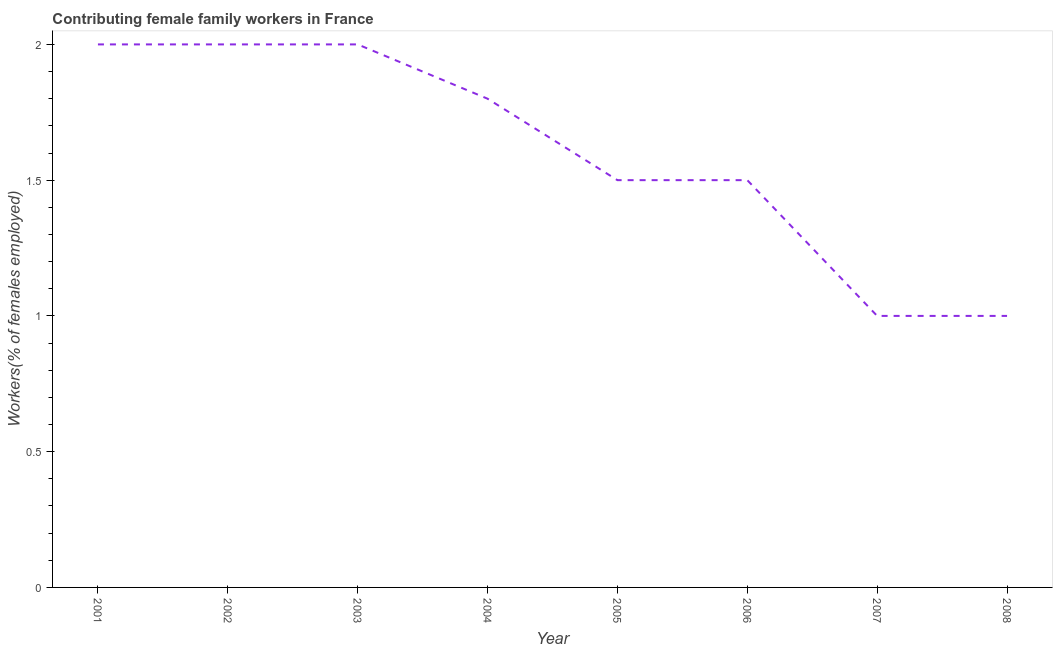Across all years, what is the minimum contributing female family workers?
Ensure brevity in your answer.  1. What is the sum of the contributing female family workers?
Offer a terse response. 12.8. What is the average contributing female family workers per year?
Your answer should be very brief. 1.6. What is the median contributing female family workers?
Offer a terse response. 1.65. In how many years, is the contributing female family workers greater than 1.1 %?
Give a very brief answer. 6. Do a majority of the years between 2001 and 2005 (inclusive) have contributing female family workers greater than 0.30000000000000004 %?
Give a very brief answer. Yes. What is the ratio of the contributing female family workers in 2004 to that in 2008?
Provide a succinct answer. 1.8. Is the sum of the contributing female family workers in 2005 and 2008 greater than the maximum contributing female family workers across all years?
Keep it short and to the point. Yes. Does the contributing female family workers monotonically increase over the years?
Provide a short and direct response. No. What is the difference between two consecutive major ticks on the Y-axis?
Provide a short and direct response. 0.5. Does the graph contain any zero values?
Provide a short and direct response. No. Does the graph contain grids?
Provide a succinct answer. No. What is the title of the graph?
Your answer should be compact. Contributing female family workers in France. What is the label or title of the X-axis?
Give a very brief answer. Year. What is the label or title of the Y-axis?
Provide a short and direct response. Workers(% of females employed). What is the Workers(% of females employed) of 2004?
Make the answer very short. 1.8. What is the Workers(% of females employed) of 2005?
Ensure brevity in your answer.  1.5. What is the difference between the Workers(% of females employed) in 2001 and 2002?
Make the answer very short. 0. What is the difference between the Workers(% of females employed) in 2001 and 2003?
Provide a succinct answer. 0. What is the difference between the Workers(% of females employed) in 2001 and 2004?
Offer a terse response. 0.2. What is the difference between the Workers(% of females employed) in 2001 and 2005?
Offer a very short reply. 0.5. What is the difference between the Workers(% of females employed) in 2001 and 2006?
Offer a terse response. 0.5. What is the difference between the Workers(% of females employed) in 2001 and 2007?
Your answer should be compact. 1. What is the difference between the Workers(% of females employed) in 2001 and 2008?
Offer a terse response. 1. What is the difference between the Workers(% of females employed) in 2002 and 2003?
Your answer should be very brief. 0. What is the difference between the Workers(% of females employed) in 2002 and 2004?
Provide a succinct answer. 0.2. What is the difference between the Workers(% of females employed) in 2002 and 2006?
Provide a short and direct response. 0.5. What is the difference between the Workers(% of females employed) in 2003 and 2006?
Your response must be concise. 0.5. What is the difference between the Workers(% of females employed) in 2003 and 2007?
Give a very brief answer. 1. What is the difference between the Workers(% of females employed) in 2003 and 2008?
Your response must be concise. 1. What is the difference between the Workers(% of females employed) in 2004 and 2007?
Offer a terse response. 0.8. What is the difference between the Workers(% of females employed) in 2004 and 2008?
Give a very brief answer. 0.8. What is the difference between the Workers(% of females employed) in 2005 and 2006?
Offer a terse response. 0. What is the difference between the Workers(% of females employed) in 2005 and 2007?
Provide a short and direct response. 0.5. What is the difference between the Workers(% of females employed) in 2006 and 2007?
Your answer should be very brief. 0.5. What is the difference between the Workers(% of females employed) in 2007 and 2008?
Offer a terse response. 0. What is the ratio of the Workers(% of females employed) in 2001 to that in 2004?
Provide a succinct answer. 1.11. What is the ratio of the Workers(% of females employed) in 2001 to that in 2005?
Your answer should be compact. 1.33. What is the ratio of the Workers(% of females employed) in 2001 to that in 2006?
Give a very brief answer. 1.33. What is the ratio of the Workers(% of females employed) in 2001 to that in 2008?
Provide a short and direct response. 2. What is the ratio of the Workers(% of females employed) in 2002 to that in 2003?
Keep it short and to the point. 1. What is the ratio of the Workers(% of females employed) in 2002 to that in 2004?
Provide a short and direct response. 1.11. What is the ratio of the Workers(% of females employed) in 2002 to that in 2005?
Provide a short and direct response. 1.33. What is the ratio of the Workers(% of females employed) in 2002 to that in 2006?
Your response must be concise. 1.33. What is the ratio of the Workers(% of females employed) in 2002 to that in 2008?
Ensure brevity in your answer.  2. What is the ratio of the Workers(% of females employed) in 2003 to that in 2004?
Provide a succinct answer. 1.11. What is the ratio of the Workers(% of females employed) in 2003 to that in 2005?
Provide a short and direct response. 1.33. What is the ratio of the Workers(% of females employed) in 2003 to that in 2006?
Make the answer very short. 1.33. What is the ratio of the Workers(% of females employed) in 2003 to that in 2007?
Keep it short and to the point. 2. What is the ratio of the Workers(% of females employed) in 2004 to that in 2005?
Provide a short and direct response. 1.2. What is the ratio of the Workers(% of females employed) in 2004 to that in 2007?
Give a very brief answer. 1.8. What is the ratio of the Workers(% of females employed) in 2005 to that in 2006?
Provide a succinct answer. 1. What is the ratio of the Workers(% of females employed) in 2005 to that in 2008?
Offer a very short reply. 1.5. What is the ratio of the Workers(% of females employed) in 2006 to that in 2007?
Provide a succinct answer. 1.5. 